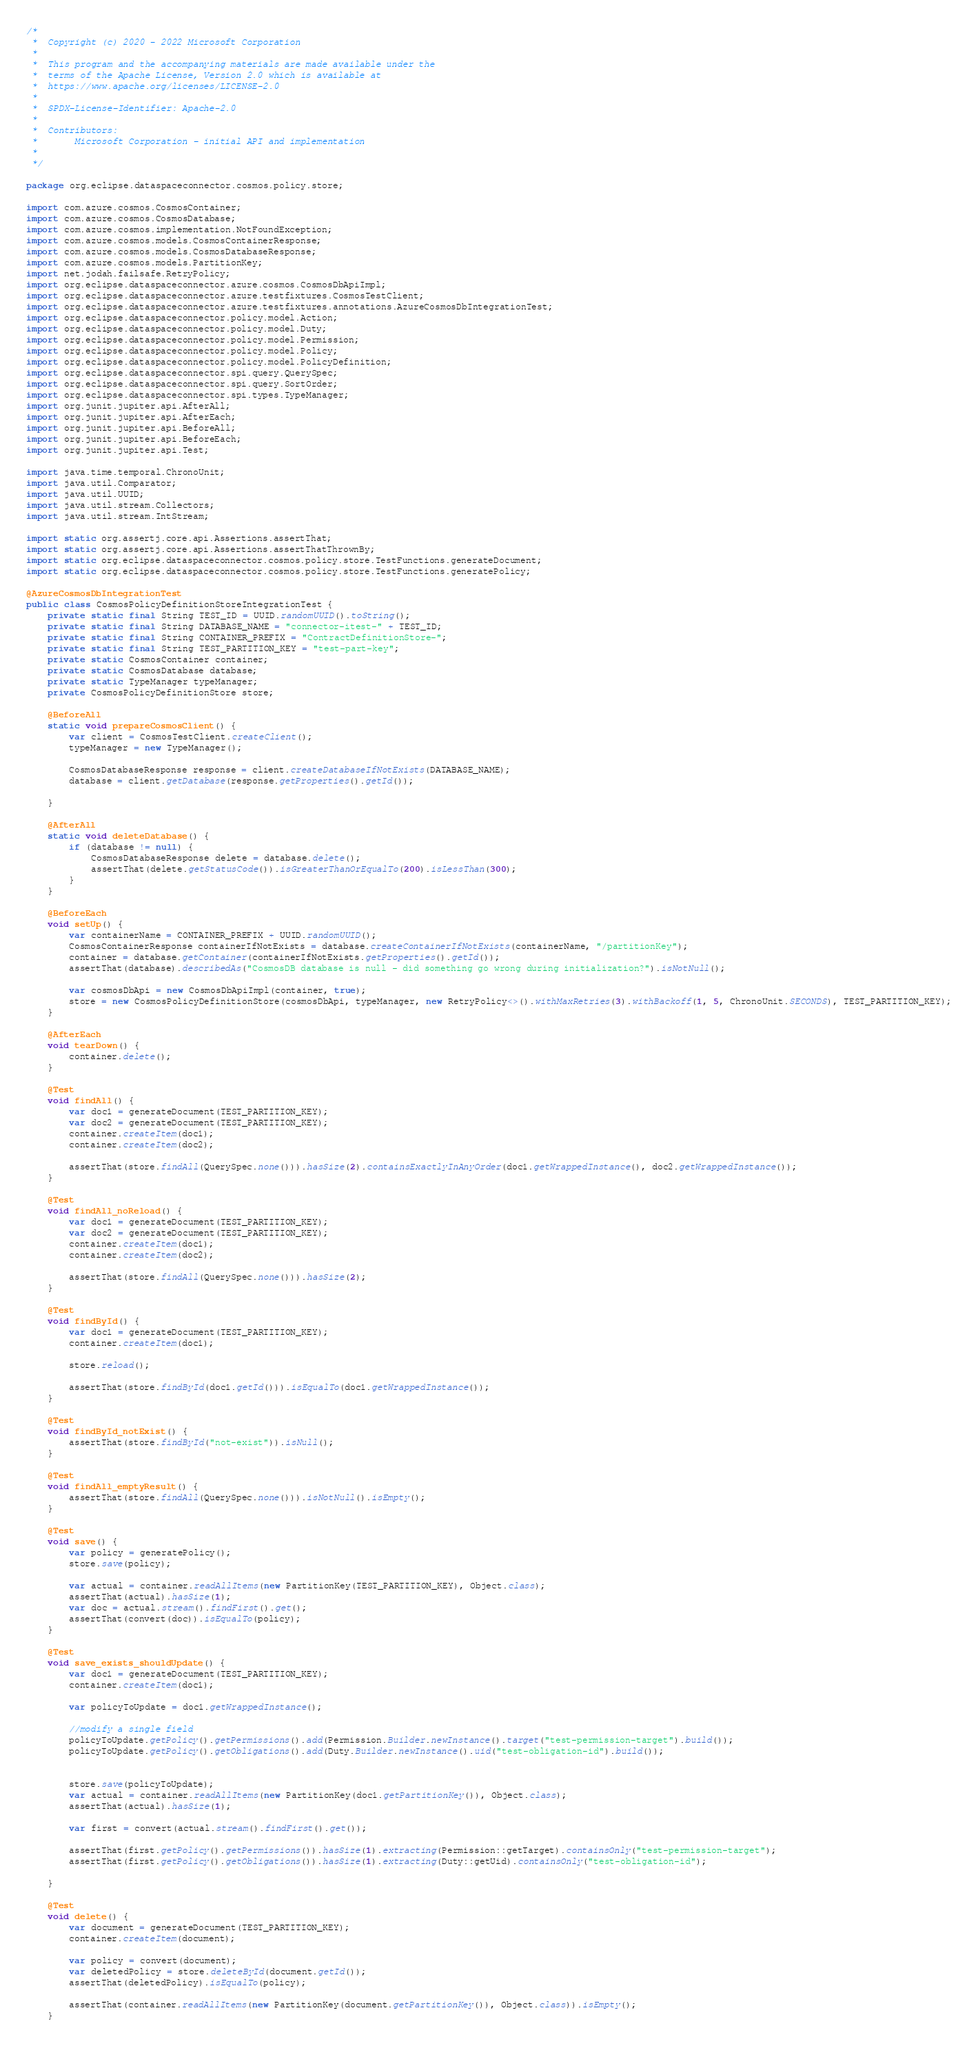Convert code to text. <code><loc_0><loc_0><loc_500><loc_500><_Java_>/*
 *  Copyright (c) 2020 - 2022 Microsoft Corporation
 *
 *  This program and the accompanying materials are made available under the
 *  terms of the Apache License, Version 2.0 which is available at
 *  https://www.apache.org/licenses/LICENSE-2.0
 *
 *  SPDX-License-Identifier: Apache-2.0
 *
 *  Contributors:
 *       Microsoft Corporation - initial API and implementation
 *
 */

package org.eclipse.dataspaceconnector.cosmos.policy.store;

import com.azure.cosmos.CosmosContainer;
import com.azure.cosmos.CosmosDatabase;
import com.azure.cosmos.implementation.NotFoundException;
import com.azure.cosmos.models.CosmosContainerResponse;
import com.azure.cosmos.models.CosmosDatabaseResponse;
import com.azure.cosmos.models.PartitionKey;
import net.jodah.failsafe.RetryPolicy;
import org.eclipse.dataspaceconnector.azure.cosmos.CosmosDbApiImpl;
import org.eclipse.dataspaceconnector.azure.testfixtures.CosmosTestClient;
import org.eclipse.dataspaceconnector.azure.testfixtures.annotations.AzureCosmosDbIntegrationTest;
import org.eclipse.dataspaceconnector.policy.model.Action;
import org.eclipse.dataspaceconnector.policy.model.Duty;
import org.eclipse.dataspaceconnector.policy.model.Permission;
import org.eclipse.dataspaceconnector.policy.model.Policy;
import org.eclipse.dataspaceconnector.policy.model.PolicyDefinition;
import org.eclipse.dataspaceconnector.spi.query.QuerySpec;
import org.eclipse.dataspaceconnector.spi.query.SortOrder;
import org.eclipse.dataspaceconnector.spi.types.TypeManager;
import org.junit.jupiter.api.AfterAll;
import org.junit.jupiter.api.AfterEach;
import org.junit.jupiter.api.BeforeAll;
import org.junit.jupiter.api.BeforeEach;
import org.junit.jupiter.api.Test;

import java.time.temporal.ChronoUnit;
import java.util.Comparator;
import java.util.UUID;
import java.util.stream.Collectors;
import java.util.stream.IntStream;

import static org.assertj.core.api.Assertions.assertThat;
import static org.assertj.core.api.Assertions.assertThatThrownBy;
import static org.eclipse.dataspaceconnector.cosmos.policy.store.TestFunctions.generateDocument;
import static org.eclipse.dataspaceconnector.cosmos.policy.store.TestFunctions.generatePolicy;

@AzureCosmosDbIntegrationTest
public class CosmosPolicyDefinitionStoreIntegrationTest {
    private static final String TEST_ID = UUID.randomUUID().toString();
    private static final String DATABASE_NAME = "connector-itest-" + TEST_ID;
    private static final String CONTAINER_PREFIX = "ContractDefinitionStore-";
    private static final String TEST_PARTITION_KEY = "test-part-key";
    private static CosmosContainer container;
    private static CosmosDatabase database;
    private static TypeManager typeManager;
    private CosmosPolicyDefinitionStore store;

    @BeforeAll
    static void prepareCosmosClient() {
        var client = CosmosTestClient.createClient();
        typeManager = new TypeManager();

        CosmosDatabaseResponse response = client.createDatabaseIfNotExists(DATABASE_NAME);
        database = client.getDatabase(response.getProperties().getId());

    }

    @AfterAll
    static void deleteDatabase() {
        if (database != null) {
            CosmosDatabaseResponse delete = database.delete();
            assertThat(delete.getStatusCode()).isGreaterThanOrEqualTo(200).isLessThan(300);
        }
    }

    @BeforeEach
    void setUp() {
        var containerName = CONTAINER_PREFIX + UUID.randomUUID();
        CosmosContainerResponse containerIfNotExists = database.createContainerIfNotExists(containerName, "/partitionKey");
        container = database.getContainer(containerIfNotExists.getProperties().getId());
        assertThat(database).describedAs("CosmosDB database is null - did something go wrong during initialization?").isNotNull();

        var cosmosDbApi = new CosmosDbApiImpl(container, true);
        store = new CosmosPolicyDefinitionStore(cosmosDbApi, typeManager, new RetryPolicy<>().withMaxRetries(3).withBackoff(1, 5, ChronoUnit.SECONDS), TEST_PARTITION_KEY);
    }

    @AfterEach
    void tearDown() {
        container.delete();
    }

    @Test
    void findAll() {
        var doc1 = generateDocument(TEST_PARTITION_KEY);
        var doc2 = generateDocument(TEST_PARTITION_KEY);
        container.createItem(doc1);
        container.createItem(doc2);

        assertThat(store.findAll(QuerySpec.none())).hasSize(2).containsExactlyInAnyOrder(doc1.getWrappedInstance(), doc2.getWrappedInstance());
    }

    @Test
    void findAll_noReload() {
        var doc1 = generateDocument(TEST_PARTITION_KEY);
        var doc2 = generateDocument(TEST_PARTITION_KEY);
        container.createItem(doc1);
        container.createItem(doc2);

        assertThat(store.findAll(QuerySpec.none())).hasSize(2);
    }

    @Test
    void findById() {
        var doc1 = generateDocument(TEST_PARTITION_KEY);
        container.createItem(doc1);

        store.reload();

        assertThat(store.findById(doc1.getId())).isEqualTo(doc1.getWrappedInstance());
    }

    @Test
    void findById_notExist() {
        assertThat(store.findById("not-exist")).isNull();
    }

    @Test
    void findAll_emptyResult() {
        assertThat(store.findAll(QuerySpec.none())).isNotNull().isEmpty();
    }

    @Test
    void save() {
        var policy = generatePolicy();
        store.save(policy);

        var actual = container.readAllItems(new PartitionKey(TEST_PARTITION_KEY), Object.class);
        assertThat(actual).hasSize(1);
        var doc = actual.stream().findFirst().get();
        assertThat(convert(doc)).isEqualTo(policy);
    }

    @Test
    void save_exists_shouldUpdate() {
        var doc1 = generateDocument(TEST_PARTITION_KEY);
        container.createItem(doc1);

        var policyToUpdate = doc1.getWrappedInstance();

        //modify a single field
        policyToUpdate.getPolicy().getPermissions().add(Permission.Builder.newInstance().target("test-permission-target").build());
        policyToUpdate.getPolicy().getObligations().add(Duty.Builder.newInstance().uid("test-obligation-id").build());


        store.save(policyToUpdate);
        var actual = container.readAllItems(new PartitionKey(doc1.getPartitionKey()), Object.class);
        assertThat(actual).hasSize(1);

        var first = convert(actual.stream().findFirst().get());

        assertThat(first.getPolicy().getPermissions()).hasSize(1).extracting(Permission::getTarget).containsOnly("test-permission-target");
        assertThat(first.getPolicy().getObligations()).hasSize(1).extracting(Duty::getUid).containsOnly("test-obligation-id");

    }

    @Test
    void delete() {
        var document = generateDocument(TEST_PARTITION_KEY);
        container.createItem(document);

        var policy = convert(document);
        var deletedPolicy = store.deleteById(document.getId());
        assertThat(deletedPolicy).isEqualTo(policy);

        assertThat(container.readAllItems(new PartitionKey(document.getPartitionKey()), Object.class)).isEmpty();
    }
</code> 